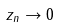Convert formula to latex. <formula><loc_0><loc_0><loc_500><loc_500>z _ { n } \rightarrow 0</formula> 